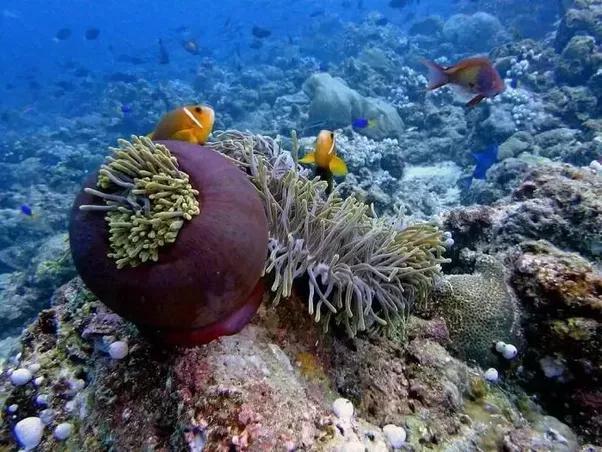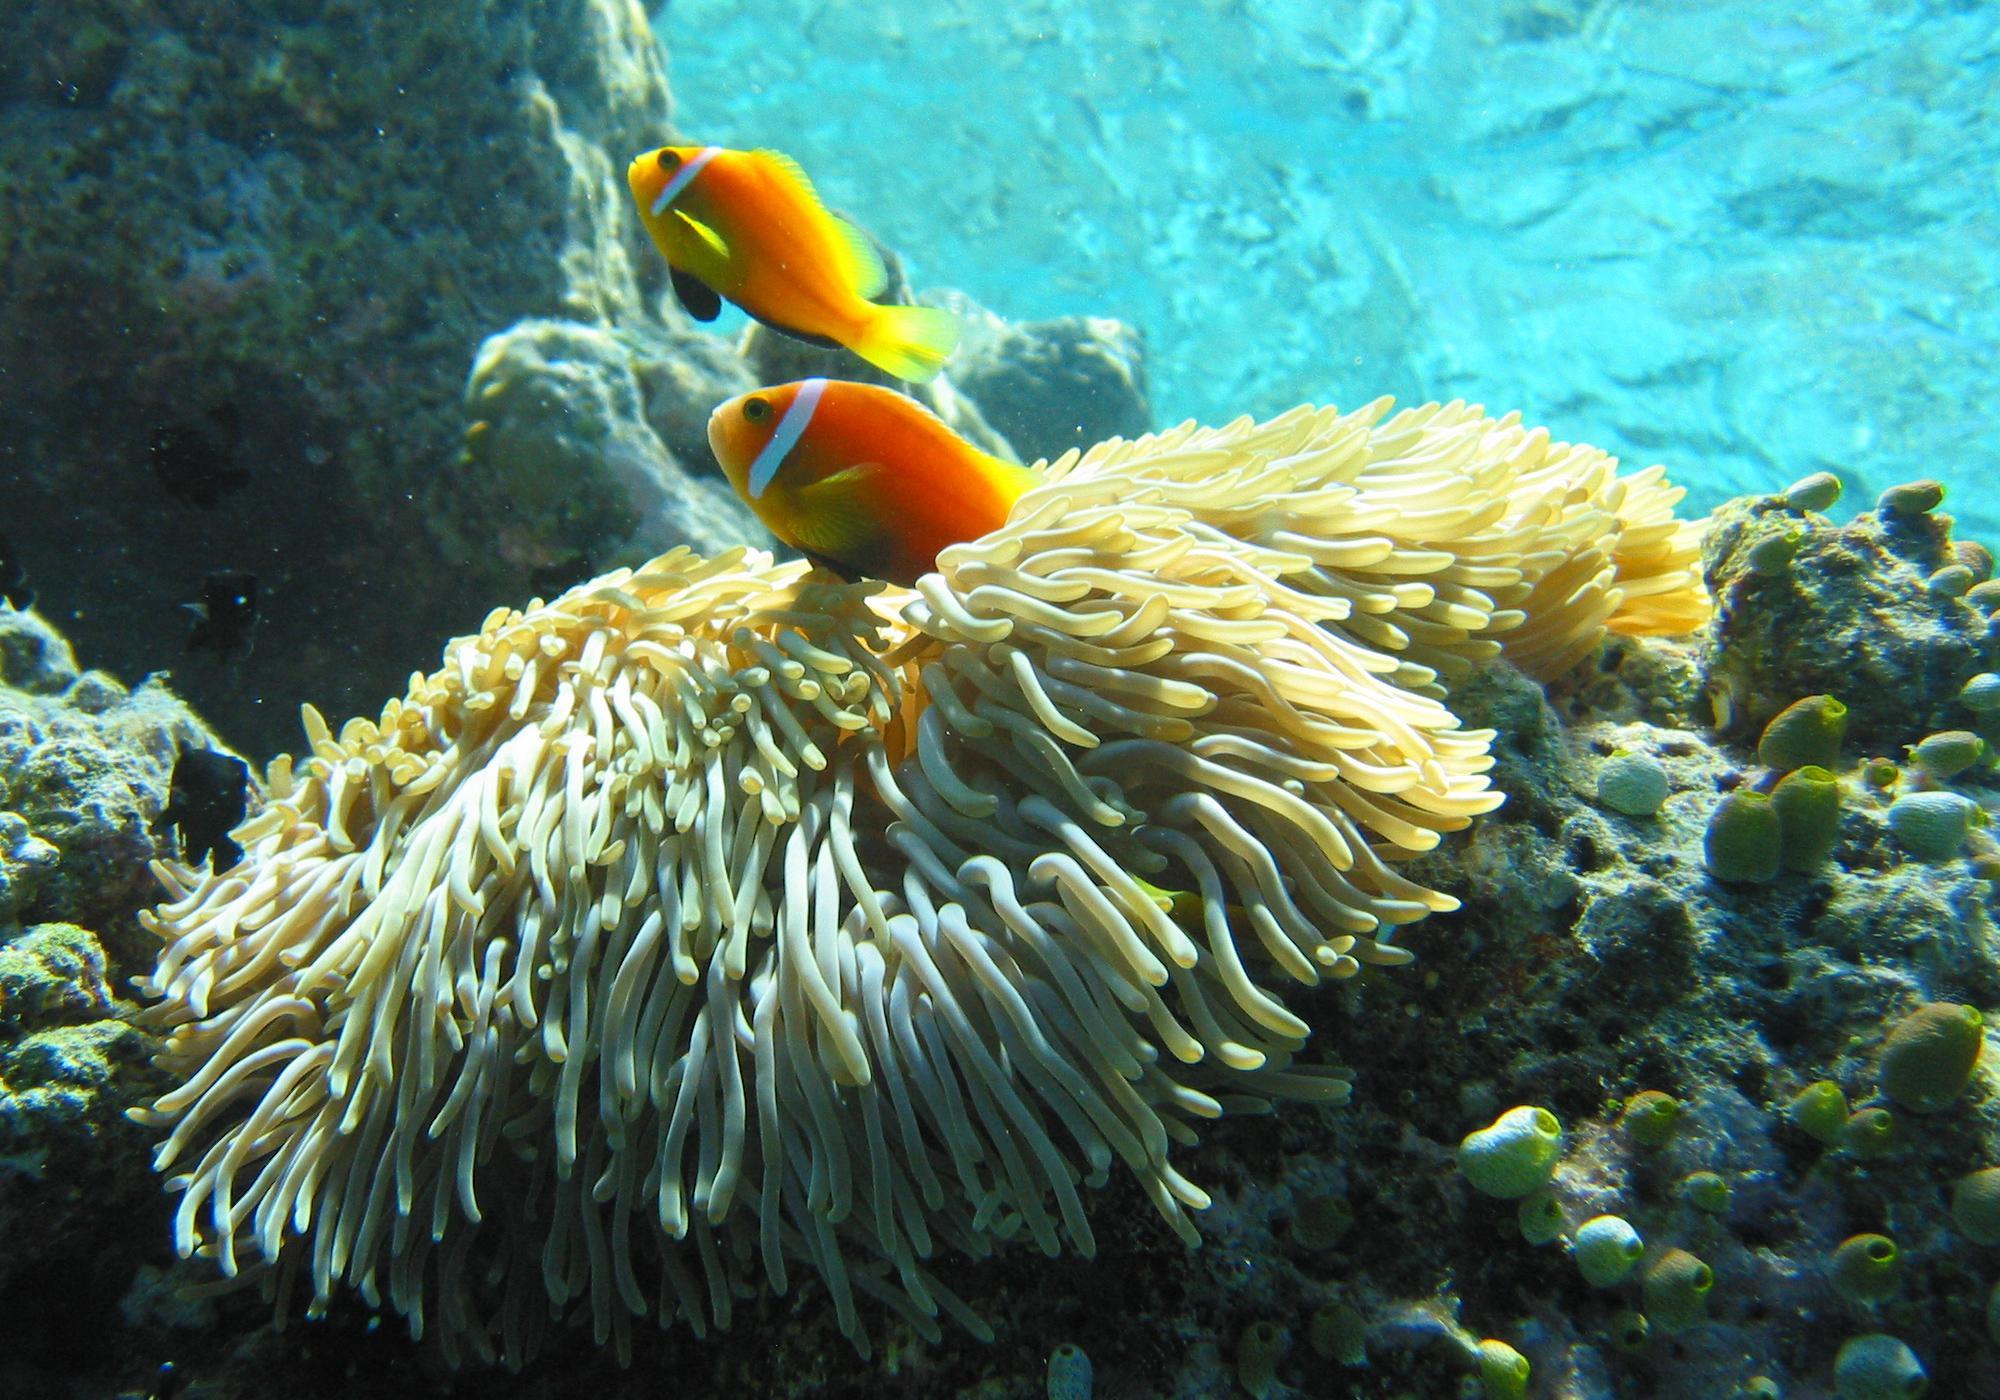The first image is the image on the left, the second image is the image on the right. For the images displayed, is the sentence "There are no more than two fish in the image on the left." factually correct? Answer yes or no. No. 